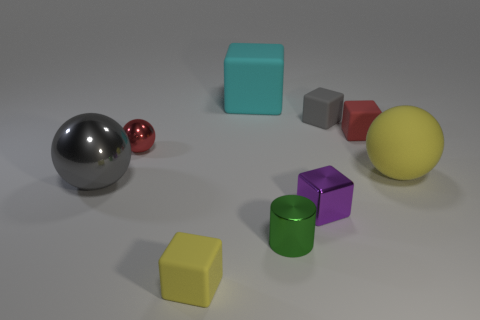There is a large rubber thing on the right side of the cyan thing; does it have the same color as the large block?
Your answer should be very brief. No. The red thing that is behind the red object on the left side of the gray object behind the large gray ball is what shape?
Make the answer very short. Cube. There is a yellow rubber block; is it the same size as the red thing to the right of the tiny purple shiny thing?
Offer a very short reply. Yes. Are there any purple things of the same size as the green thing?
Ensure brevity in your answer.  Yes. What number of other objects are there of the same material as the yellow sphere?
Ensure brevity in your answer.  4. What is the color of the block that is both on the right side of the small purple metal thing and behind the red rubber block?
Provide a short and direct response. Gray. Do the thing left of the small shiny ball and the block that is in front of the green shiny cylinder have the same material?
Your answer should be very brief. No. Does the object in front of the green cylinder have the same size as the gray shiny ball?
Ensure brevity in your answer.  No. Is the color of the big metallic object the same as the tiny cube behind the red rubber cube?
Provide a short and direct response. Yes. What is the shape of the small thing that is the same color as the large metal sphere?
Give a very brief answer. Cube. 